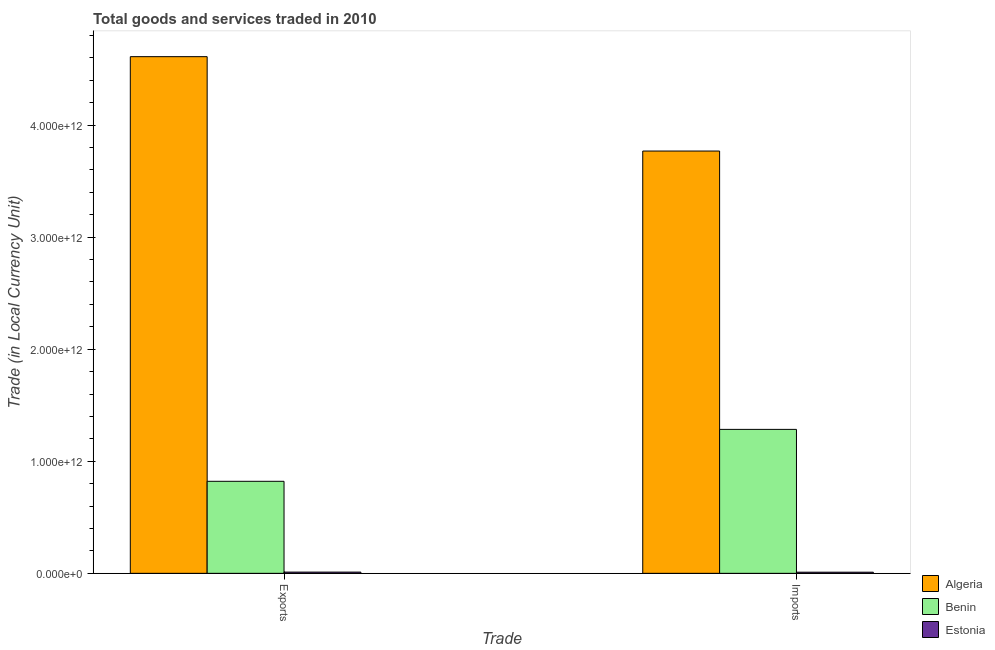How many groups of bars are there?
Your response must be concise. 2. How many bars are there on the 1st tick from the left?
Offer a very short reply. 3. What is the label of the 1st group of bars from the left?
Make the answer very short. Exports. What is the imports of goods and services in Algeria?
Your answer should be very brief. 3.77e+12. Across all countries, what is the maximum imports of goods and services?
Give a very brief answer. 3.77e+12. Across all countries, what is the minimum export of goods and services?
Provide a succinct answer. 1.10e+1. In which country was the export of goods and services maximum?
Your answer should be very brief. Algeria. In which country was the export of goods and services minimum?
Provide a short and direct response. Estonia. What is the total export of goods and services in the graph?
Offer a terse response. 5.44e+12. What is the difference between the imports of goods and services in Algeria and that in Estonia?
Give a very brief answer. 3.76e+12. What is the difference between the export of goods and services in Algeria and the imports of goods and services in Benin?
Your response must be concise. 3.33e+12. What is the average export of goods and services per country?
Make the answer very short. 1.81e+12. What is the difference between the imports of goods and services and export of goods and services in Benin?
Your answer should be very brief. 4.63e+11. In how many countries, is the export of goods and services greater than 600000000000 LCU?
Your response must be concise. 2. What is the ratio of the export of goods and services in Estonia to that in Benin?
Your answer should be very brief. 0.01. Is the export of goods and services in Benin less than that in Estonia?
Offer a very short reply. No. What does the 2nd bar from the left in Exports represents?
Give a very brief answer. Benin. What does the 1st bar from the right in Exports represents?
Ensure brevity in your answer.  Estonia. Are all the bars in the graph horizontal?
Make the answer very short. No. What is the difference between two consecutive major ticks on the Y-axis?
Offer a terse response. 1.00e+12. Are the values on the major ticks of Y-axis written in scientific E-notation?
Keep it short and to the point. Yes. Does the graph contain any zero values?
Provide a succinct answer. No. Does the graph contain grids?
Ensure brevity in your answer.  No. Where does the legend appear in the graph?
Your answer should be compact. Bottom right. How many legend labels are there?
Provide a short and direct response. 3. What is the title of the graph?
Provide a short and direct response. Total goods and services traded in 2010. Does "Denmark" appear as one of the legend labels in the graph?
Provide a short and direct response. No. What is the label or title of the X-axis?
Give a very brief answer. Trade. What is the label or title of the Y-axis?
Keep it short and to the point. Trade (in Local Currency Unit). What is the Trade (in Local Currency Unit) in Algeria in Exports?
Ensure brevity in your answer.  4.61e+12. What is the Trade (in Local Currency Unit) of Benin in Exports?
Provide a short and direct response. 8.21e+11. What is the Trade (in Local Currency Unit) of Estonia in Exports?
Provide a succinct answer. 1.10e+1. What is the Trade (in Local Currency Unit) of Algeria in Imports?
Make the answer very short. 3.77e+12. What is the Trade (in Local Currency Unit) of Benin in Imports?
Keep it short and to the point. 1.28e+12. What is the Trade (in Local Currency Unit) of Estonia in Imports?
Offer a very short reply. 1.01e+1. Across all Trade, what is the maximum Trade (in Local Currency Unit) in Algeria?
Keep it short and to the point. 4.61e+12. Across all Trade, what is the maximum Trade (in Local Currency Unit) in Benin?
Offer a terse response. 1.28e+12. Across all Trade, what is the maximum Trade (in Local Currency Unit) of Estonia?
Your answer should be compact. 1.10e+1. Across all Trade, what is the minimum Trade (in Local Currency Unit) in Algeria?
Your answer should be very brief. 3.77e+12. Across all Trade, what is the minimum Trade (in Local Currency Unit) in Benin?
Ensure brevity in your answer.  8.21e+11. Across all Trade, what is the minimum Trade (in Local Currency Unit) of Estonia?
Provide a short and direct response. 1.01e+1. What is the total Trade (in Local Currency Unit) of Algeria in the graph?
Your answer should be very brief. 8.38e+12. What is the total Trade (in Local Currency Unit) of Benin in the graph?
Offer a very short reply. 2.11e+12. What is the total Trade (in Local Currency Unit) in Estonia in the graph?
Give a very brief answer. 2.12e+1. What is the difference between the Trade (in Local Currency Unit) in Algeria in Exports and that in Imports?
Give a very brief answer. 8.42e+11. What is the difference between the Trade (in Local Currency Unit) in Benin in Exports and that in Imports?
Provide a short and direct response. -4.63e+11. What is the difference between the Trade (in Local Currency Unit) of Estonia in Exports and that in Imports?
Your answer should be compact. 9.35e+08. What is the difference between the Trade (in Local Currency Unit) of Algeria in Exports and the Trade (in Local Currency Unit) of Benin in Imports?
Provide a short and direct response. 3.33e+12. What is the difference between the Trade (in Local Currency Unit) in Algeria in Exports and the Trade (in Local Currency Unit) in Estonia in Imports?
Your response must be concise. 4.60e+12. What is the difference between the Trade (in Local Currency Unit) of Benin in Exports and the Trade (in Local Currency Unit) of Estonia in Imports?
Offer a very short reply. 8.11e+11. What is the average Trade (in Local Currency Unit) in Algeria per Trade?
Make the answer very short. 4.19e+12. What is the average Trade (in Local Currency Unit) of Benin per Trade?
Provide a succinct answer. 1.05e+12. What is the average Trade (in Local Currency Unit) in Estonia per Trade?
Make the answer very short. 1.06e+1. What is the difference between the Trade (in Local Currency Unit) in Algeria and Trade (in Local Currency Unit) in Benin in Exports?
Offer a terse response. 3.79e+12. What is the difference between the Trade (in Local Currency Unit) of Algeria and Trade (in Local Currency Unit) of Estonia in Exports?
Offer a very short reply. 4.60e+12. What is the difference between the Trade (in Local Currency Unit) of Benin and Trade (in Local Currency Unit) of Estonia in Exports?
Give a very brief answer. 8.10e+11. What is the difference between the Trade (in Local Currency Unit) of Algeria and Trade (in Local Currency Unit) of Benin in Imports?
Your answer should be compact. 2.48e+12. What is the difference between the Trade (in Local Currency Unit) of Algeria and Trade (in Local Currency Unit) of Estonia in Imports?
Your response must be concise. 3.76e+12. What is the difference between the Trade (in Local Currency Unit) of Benin and Trade (in Local Currency Unit) of Estonia in Imports?
Give a very brief answer. 1.27e+12. What is the ratio of the Trade (in Local Currency Unit) of Algeria in Exports to that in Imports?
Your answer should be very brief. 1.22. What is the ratio of the Trade (in Local Currency Unit) of Benin in Exports to that in Imports?
Offer a very short reply. 0.64. What is the ratio of the Trade (in Local Currency Unit) in Estonia in Exports to that in Imports?
Offer a terse response. 1.09. What is the difference between the highest and the second highest Trade (in Local Currency Unit) of Algeria?
Your answer should be very brief. 8.42e+11. What is the difference between the highest and the second highest Trade (in Local Currency Unit) in Benin?
Your answer should be compact. 4.63e+11. What is the difference between the highest and the second highest Trade (in Local Currency Unit) in Estonia?
Your answer should be compact. 9.35e+08. What is the difference between the highest and the lowest Trade (in Local Currency Unit) in Algeria?
Make the answer very short. 8.42e+11. What is the difference between the highest and the lowest Trade (in Local Currency Unit) in Benin?
Ensure brevity in your answer.  4.63e+11. What is the difference between the highest and the lowest Trade (in Local Currency Unit) in Estonia?
Ensure brevity in your answer.  9.35e+08. 